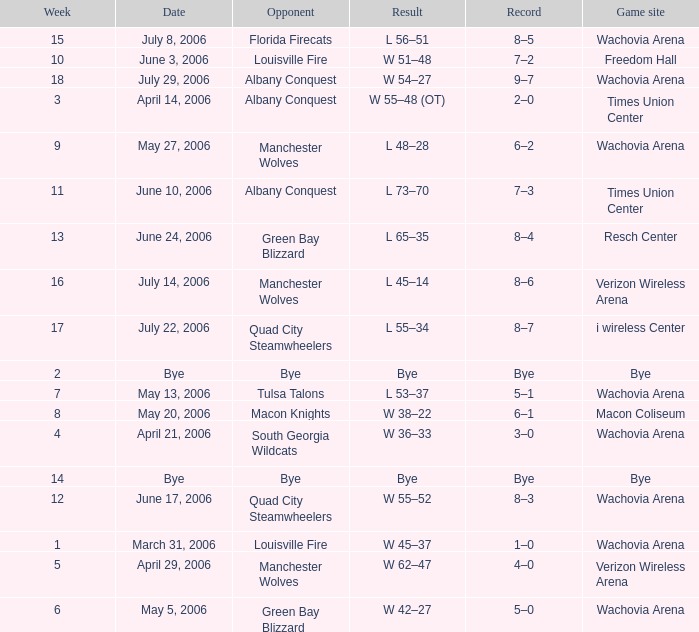What is the Game site week 1? Wachovia Arena. 